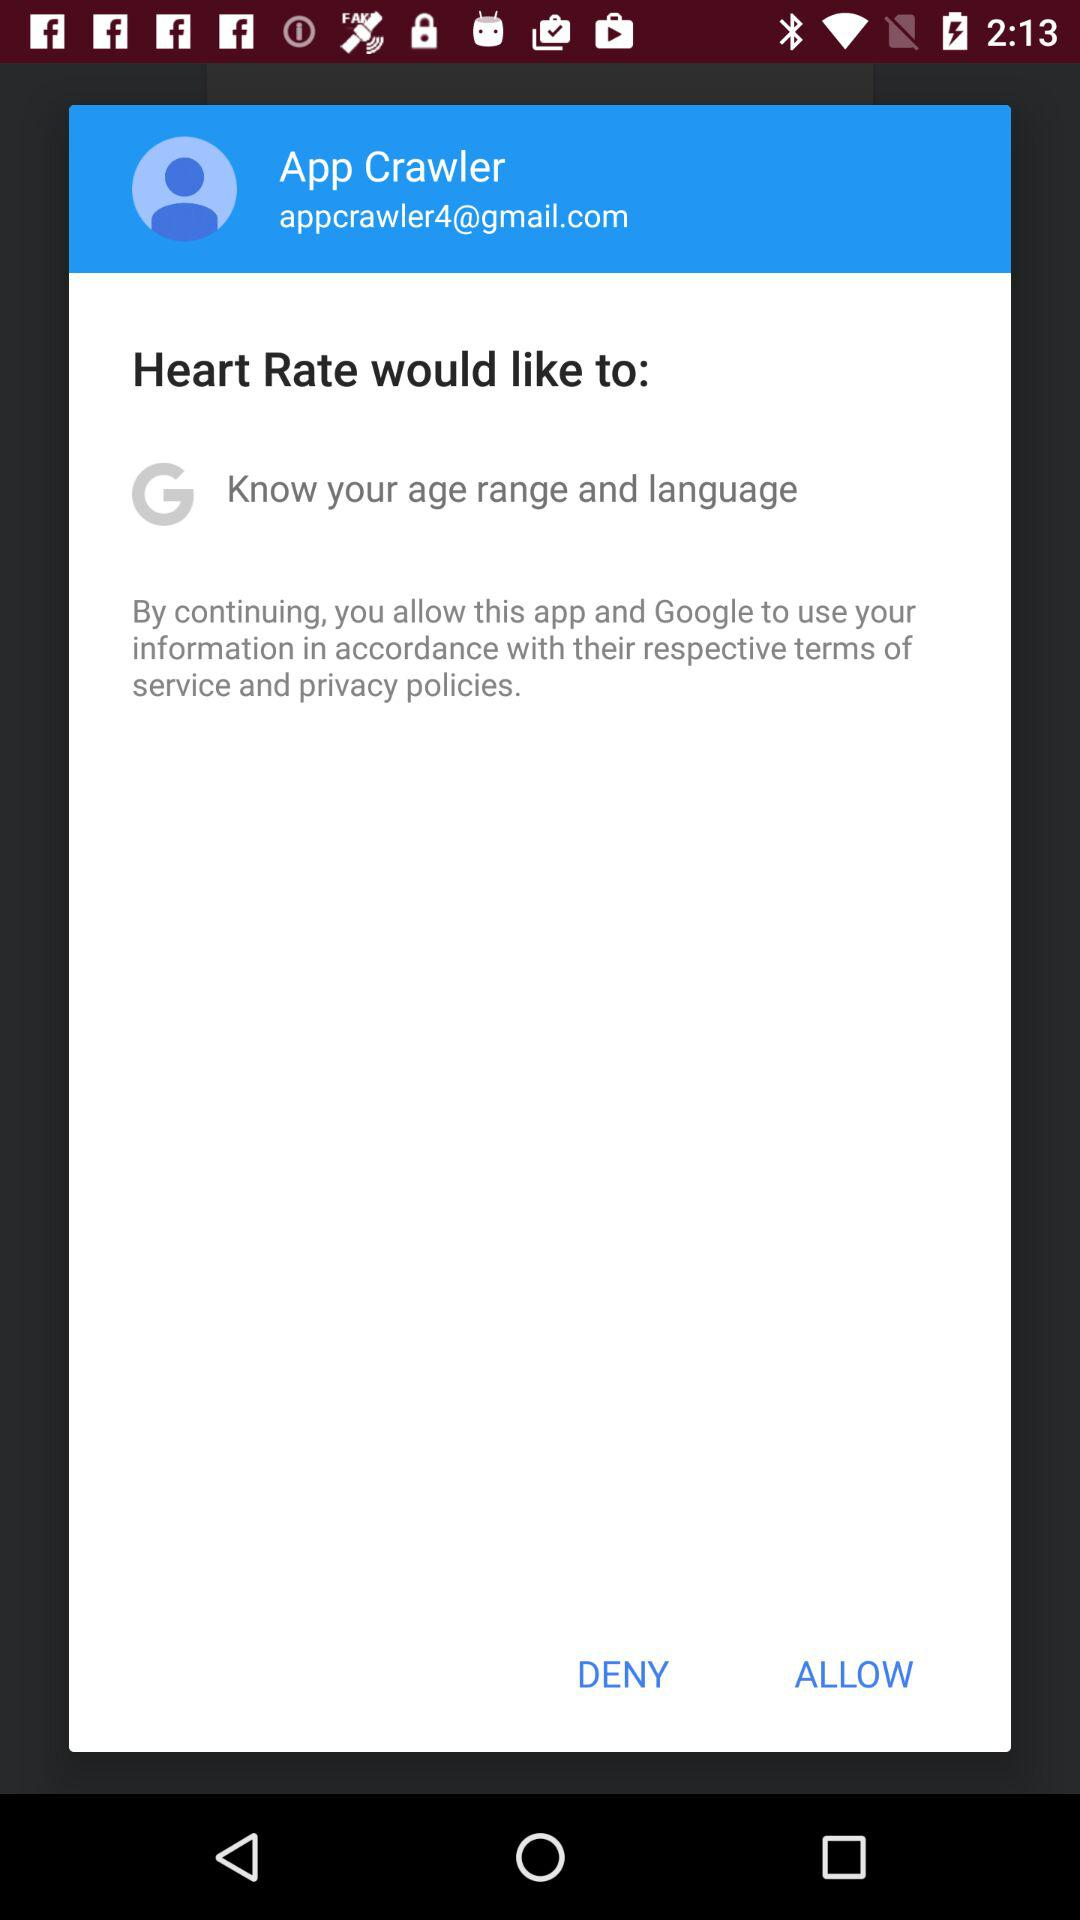What is the user name? The user name is App Crawler. 